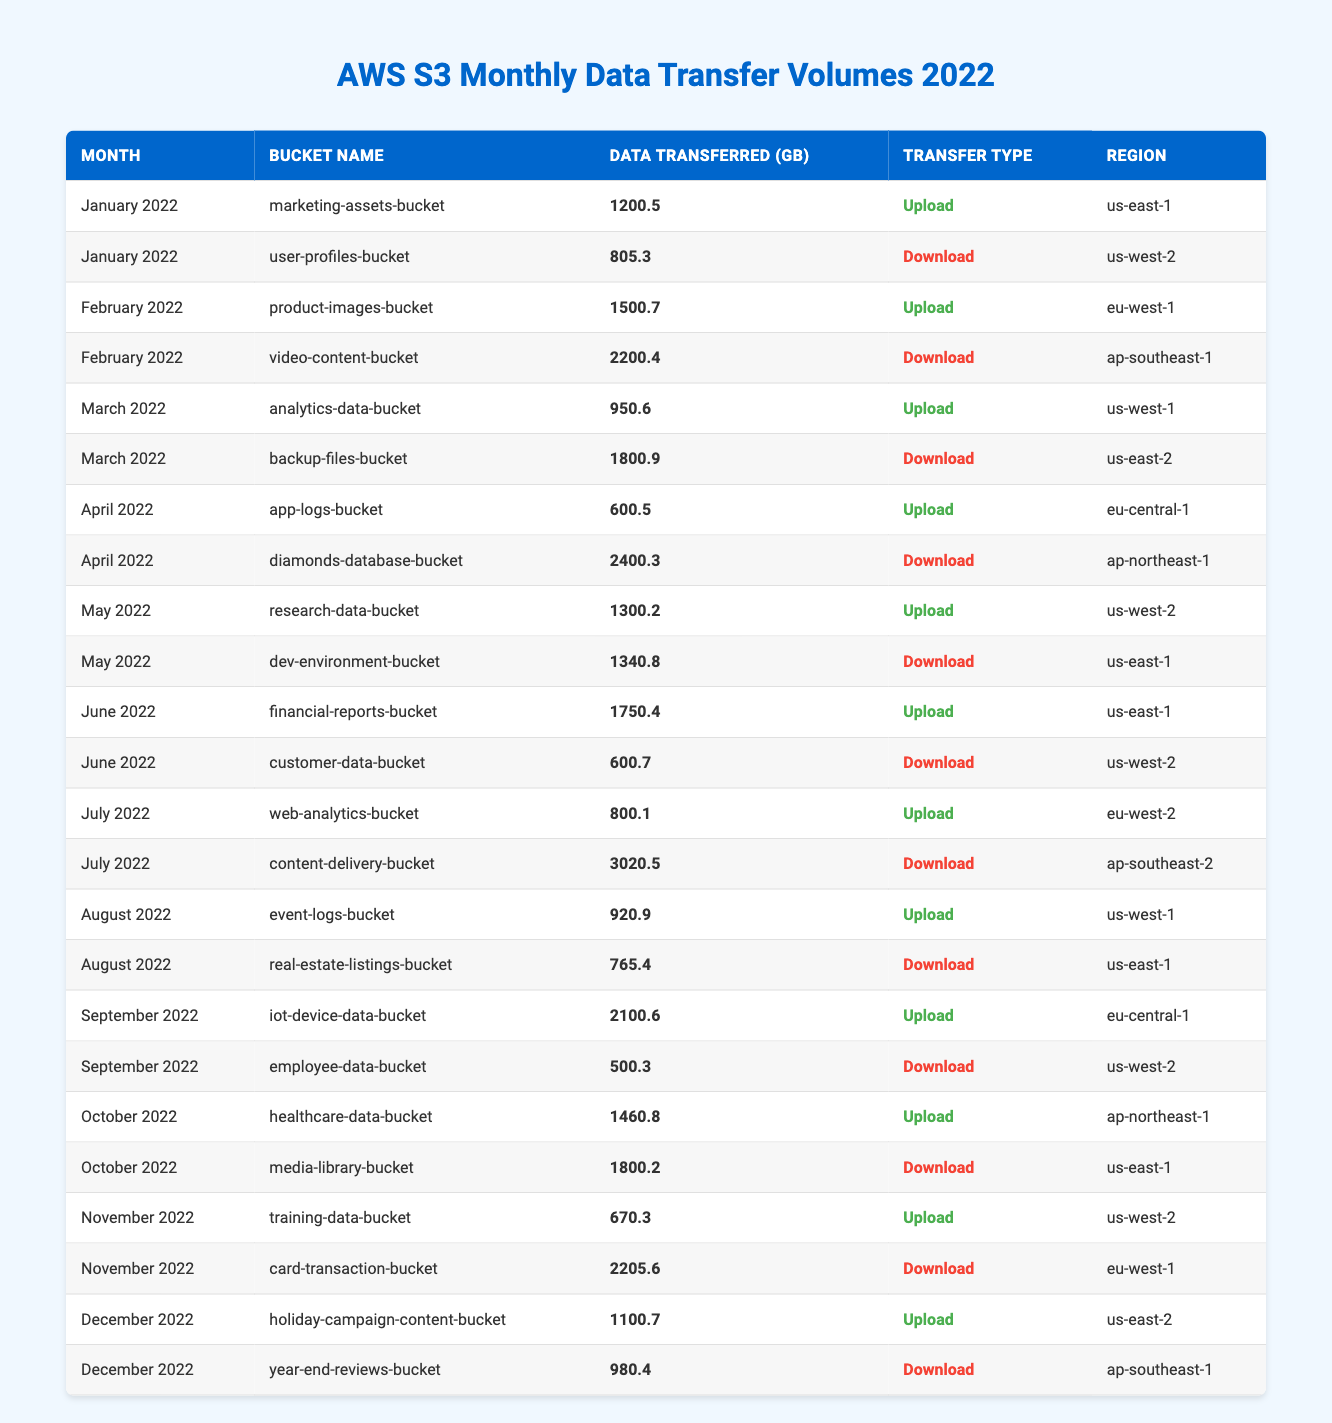What is the total data transferred for "marketing-assets-bucket" in January 2022? The data transferred for "marketing-assets-bucket" in January 2022 is specifically listed as 1200.5 GB in the table.
Answer: 1200.5 GB Which month had the highest data transfer volume for uploads? To find the highest upload volume, we can look at each month's upload data in the table: January (1200.5), February (1500.7), March (950.6), April (600.5), May (1300.2), June (1750.4), July (800.1), August (920.9), September (2100.6), October (1460.8), November (670.3), December (1100.7). The maximum is 2100.6 GB in September 2022.
Answer: September 2022 What is the total data transferred in June 2022? In June 2022, there are two entries. The total is calculated by adding the data transferred: 1750.4 GB (upload) + 600.7 GB (download) = 2351.1 GB.
Answer: 2351.1 GB Did any bucket experience a data transfer volume over 3000 GB in July 2022? The maximum download for July 2022 is 3020.5 GB from "content-delivery-bucket," which is over 3000 GB.
Answer: Yes What is the average data transfer volume for uploads in 2022? For uploads, we sum the upload volumes: 1200.5 + 1500.7 + 950.6 + 600.5 + 1300.2 + 1750.4 + 800.1 + 920.9 + 2100.6 + 1460.8 + 670.3 + 1100.7 = 13334.3 GB. There are 12 uploads, so the average is 13334.3 / 12 = 1111.19 GB.
Answer: 1111.19 GB Which region had the highest total download volume? To find this, we sum all download volumes by region: us-west-2 (805.3 + 600.7 + 500.3 + 670.3) = 2576.6, ap-southeast-1 (2200.4 + 980.4) = 3180.8, eu-west-1 (2205.6), and ap-northeast-1 (2400.3). The highest is 3180.8 from region ap-southeast-1.
Answer: ap-southeast-1 Identify the bucket with the lowest data transfer in August 2022? The only two entries for August 2022 are "event-logs-bucket" (920.9 GB) and "real-estate-listings-bucket" (765.4 GB). The lowest is 765.4 GB.
Answer: real-estate-listings-bucket How much more data was downloaded in November than uploaded? Total downloads in November: 2205.6 GB (download) - 670.3 GB (upload) = 1535.3 GB more downloaded than uploaded.
Answer: 1535.3 GB What is the month with the largest increase in upload volumes compared to the previous month? Looking at the month-to-month differences, the increase from August (920.9) to September (2100.6) is the largest: 2100.6 - 920.9 = 1179.7 GB increase.
Answer: September 2022 Was the data transferred from "video-content-bucket" greater than "backup-files-bucket"? "Video-content-bucket" has 2200.4 GB (download), while "backup-files-bucket" has 1800.9 GB (download). Thus, the transfer from "video-content-bucket" is greater.
Answer: Yes What is the total number of uploads throughout the 2022 data? The total number of uploads is determined by counting the rows where the transfer type is "Upload," resulting in 12 upload entries.
Answer: 12 